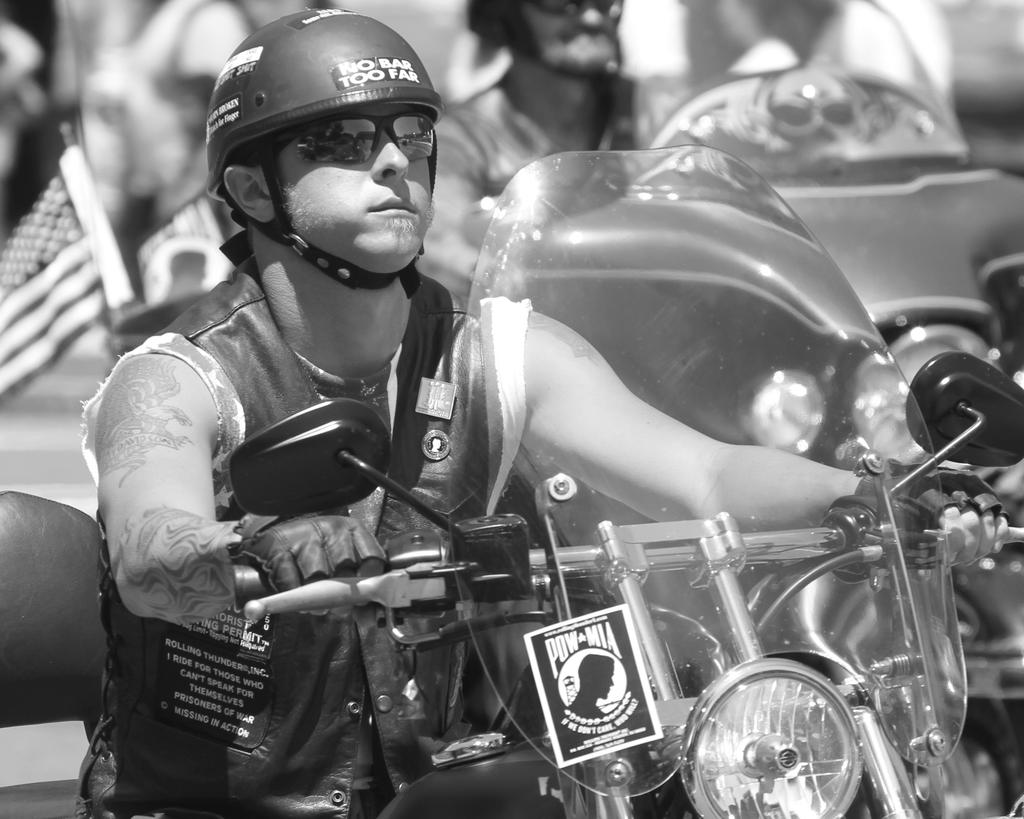How many people are in the image? There are persons in the image. What are the persons doing in the image? The persons are riding motorcycles. Where are the motorcycles located in the image? The motorcycles are in the middle of the image. How many cords are attached to the motorcycles in the image? There are no cords attached to the motorcycles in the image. What type of offer is being made by the persons on the motorcycles in the image? There is no indication of an offer being made in the image; the persons are simply riding motorcycles. 